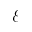<formula> <loc_0><loc_0><loc_500><loc_500>\mathcal { E }</formula> 